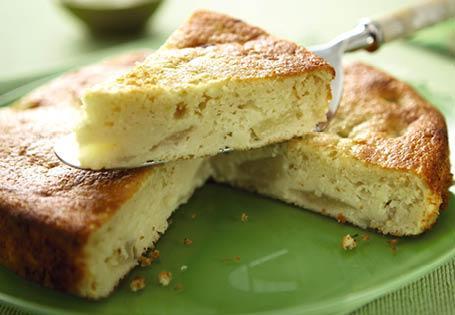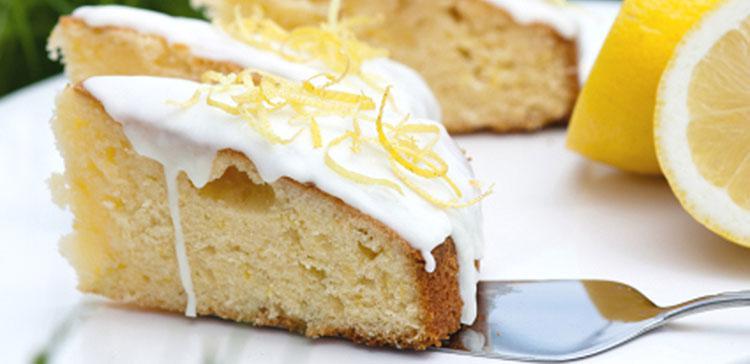The first image is the image on the left, the second image is the image on the right. Analyze the images presented: Is the assertion "there is cake with lemons being used as decorations and a metal utencil is near the cake" valid? Answer yes or no. Yes. 